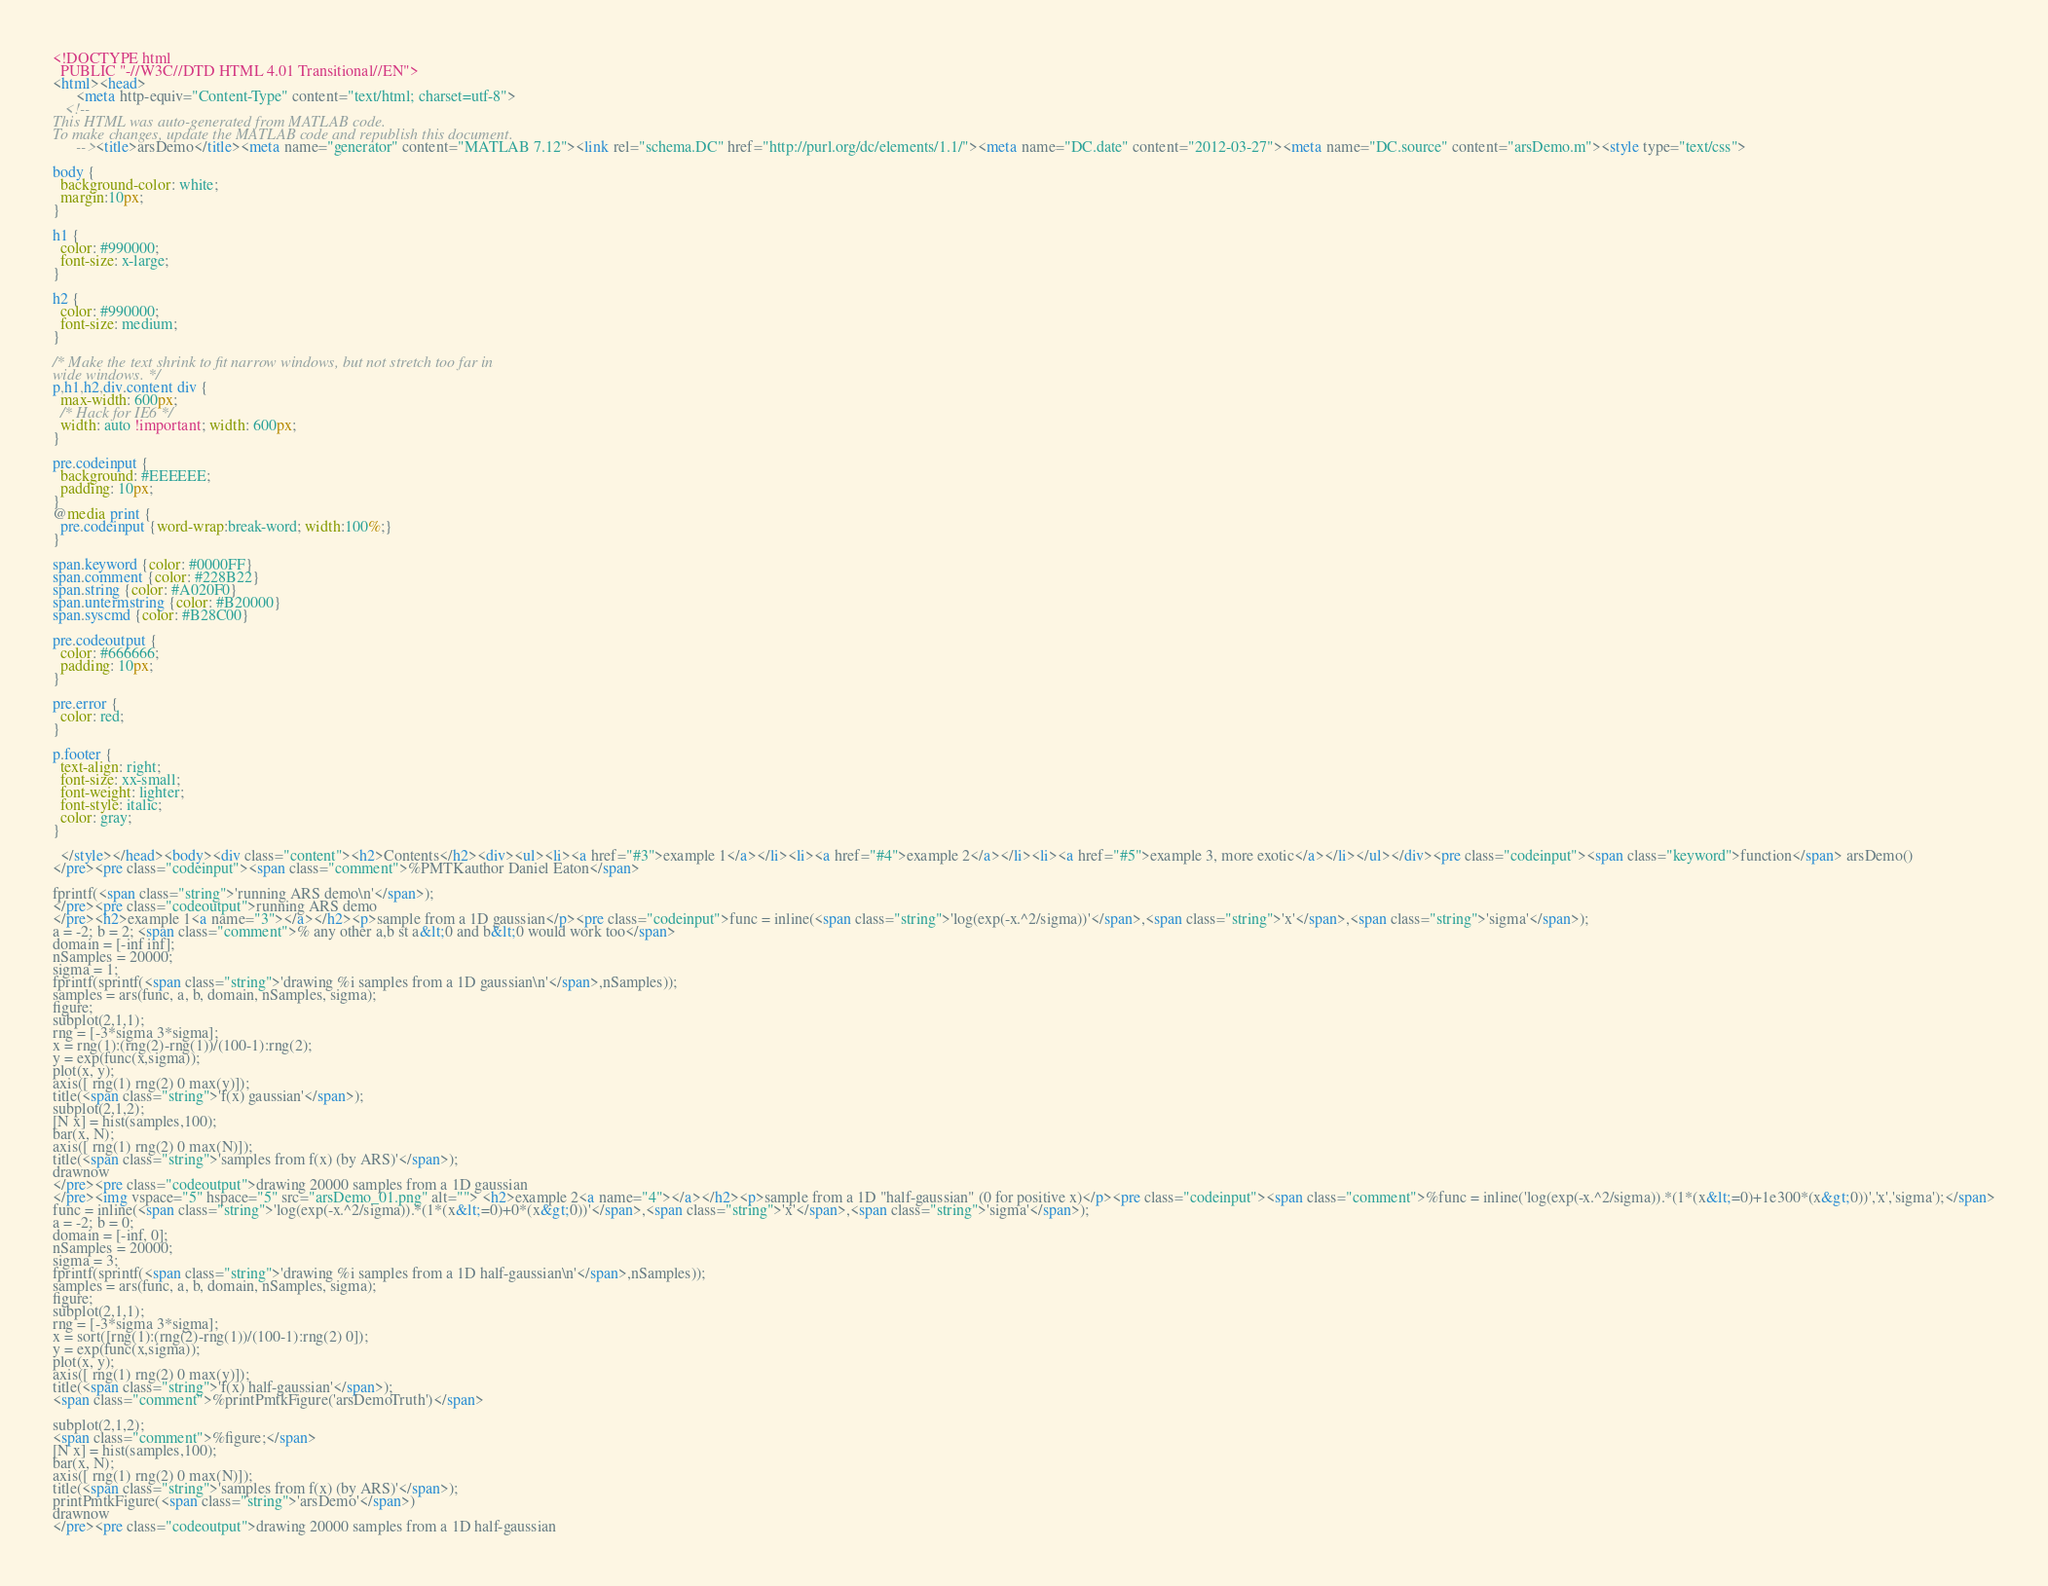<code> <loc_0><loc_0><loc_500><loc_500><_HTML_>
<!DOCTYPE html
  PUBLIC "-//W3C//DTD HTML 4.01 Transitional//EN">
<html><head>
      <meta http-equiv="Content-Type" content="text/html; charset=utf-8">
   <!--
This HTML was auto-generated from MATLAB code.
To make changes, update the MATLAB code and republish this document.
      --><title>arsDemo</title><meta name="generator" content="MATLAB 7.12"><link rel="schema.DC" href="http://purl.org/dc/elements/1.1/"><meta name="DC.date" content="2012-03-27"><meta name="DC.source" content="arsDemo.m"><style type="text/css">

body {
  background-color: white;
  margin:10px;
}

h1 {
  color: #990000; 
  font-size: x-large;
}

h2 {
  color: #990000;
  font-size: medium;
}

/* Make the text shrink to fit narrow windows, but not stretch too far in 
wide windows. */ 
p,h1,h2,div.content div {
  max-width: 600px;
  /* Hack for IE6 */
  width: auto !important; width: 600px;
}

pre.codeinput {
  background: #EEEEEE;
  padding: 10px;
}
@media print {
  pre.codeinput {word-wrap:break-word; width:100%;}
} 

span.keyword {color: #0000FF}
span.comment {color: #228B22}
span.string {color: #A020F0}
span.untermstring {color: #B20000}
span.syscmd {color: #B28C00}

pre.codeoutput {
  color: #666666;
  padding: 10px;
}

pre.error {
  color: red;
}

p.footer {
  text-align: right;
  font-size: xx-small;
  font-weight: lighter;
  font-style: italic;
  color: gray;
}

  </style></head><body><div class="content"><h2>Contents</h2><div><ul><li><a href="#3">example 1</a></li><li><a href="#4">example 2</a></li><li><a href="#5">example 3, more exotic</a></li></ul></div><pre class="codeinput"><span class="keyword">function</span> arsDemo()
</pre><pre class="codeinput"><span class="comment">%PMTKauthor Daniel Eaton</span>

fprintf(<span class="string">'running ARS demo\n'</span>);
</pre><pre class="codeoutput">running ARS demo
</pre><h2>example 1<a name="3"></a></h2><p>sample from a 1D gaussian</p><pre class="codeinput">func = inline(<span class="string">'log(exp(-x.^2/sigma))'</span>,<span class="string">'x'</span>,<span class="string">'sigma'</span>);
a = -2; b = 2; <span class="comment">% any other a,b st a&lt;0 and b&lt;0 would work too</span>
domain = [-inf inf];
nSamples = 20000;
sigma = 1;
fprintf(sprintf(<span class="string">'drawing %i samples from a 1D gaussian\n'</span>,nSamples));
samples = ars(func, a, b, domain, nSamples, sigma);
figure;
subplot(2,1,1);
rng = [-3*sigma 3*sigma];
x = rng(1):(rng(2)-rng(1))/(100-1):rng(2);
y = exp(func(x,sigma));
plot(x, y);
axis([ rng(1) rng(2) 0 max(y)]);
title(<span class="string">'f(x) gaussian'</span>);
subplot(2,1,2);
[N x] = hist(samples,100);
bar(x, N);
axis([ rng(1) rng(2) 0 max(N)]);
title(<span class="string">'samples from f(x) (by ARS)'</span>);
drawnow
</pre><pre class="codeoutput">drawing 20000 samples from a 1D gaussian
</pre><img vspace="5" hspace="5" src="arsDemo_01.png" alt=""> <h2>example 2<a name="4"></a></h2><p>sample from a 1D "half-gaussian" (0 for positive x)</p><pre class="codeinput"><span class="comment">%func = inline('log(exp(-x.^2/sigma)).*(1*(x&lt;=0)+1e300*(x&gt;0))','x','sigma');</span>
func = inline(<span class="string">'log(exp(-x.^2/sigma)).*(1*(x&lt;=0)+0*(x&gt;0))'</span>,<span class="string">'x'</span>,<span class="string">'sigma'</span>);
a = -2; b = 0;
domain = [-inf, 0];
nSamples = 20000;
sigma = 3;
fprintf(sprintf(<span class="string">'drawing %i samples from a 1D half-gaussian\n'</span>,nSamples));
samples = ars(func, a, b, domain, nSamples, sigma);
figure;
subplot(2,1,1);
rng = [-3*sigma 3*sigma];
x = sort([rng(1):(rng(2)-rng(1))/(100-1):rng(2) 0]);
y = exp(func(x,sigma));
plot(x, y);
axis([ rng(1) rng(2) 0 max(y)]);
title(<span class="string">'f(x) half-gaussian'</span>);
<span class="comment">%printPmtkFigure('arsDemoTruth')</span>

subplot(2,1,2);
<span class="comment">%figure;</span>
[N x] = hist(samples,100);
bar(x, N);
axis([ rng(1) rng(2) 0 max(N)]);
title(<span class="string">'samples from f(x) (by ARS)'</span>);
printPmtkFigure(<span class="string">'arsDemo'</span>)
drawnow
</pre><pre class="codeoutput">drawing 20000 samples from a 1D half-gaussian</code> 